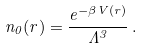<formula> <loc_0><loc_0><loc_500><loc_500>n _ { 0 } ( r ) = \frac { e ^ { - \beta V ( r ) } } { \Lambda ^ { 3 } } \, .</formula> 